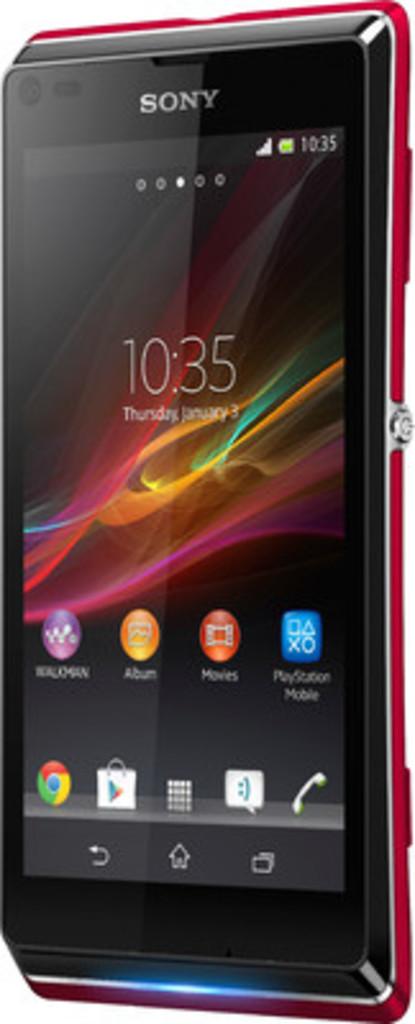What phone brand is this?
Give a very brief answer. Sony. What time is it?
Your answer should be compact. 10:35. 